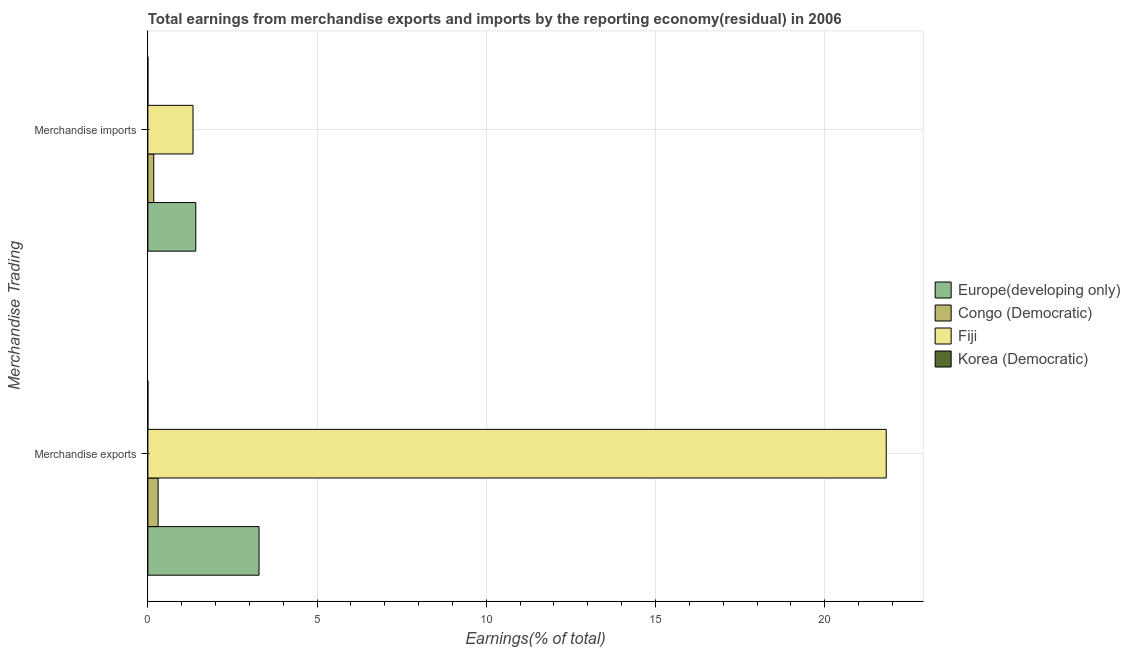How many groups of bars are there?
Give a very brief answer. 2. Are the number of bars per tick equal to the number of legend labels?
Your answer should be very brief. Yes. Are the number of bars on each tick of the Y-axis equal?
Give a very brief answer. Yes. How many bars are there on the 2nd tick from the top?
Offer a very short reply. 4. What is the earnings from merchandise imports in Korea (Democratic)?
Provide a short and direct response. 4.05073146666651e-10. Across all countries, what is the maximum earnings from merchandise imports?
Give a very brief answer. 1.42. Across all countries, what is the minimum earnings from merchandise exports?
Offer a terse response. 2.09451206696143e-8. In which country was the earnings from merchandise exports maximum?
Offer a very short reply. Fiji. In which country was the earnings from merchandise exports minimum?
Provide a succinct answer. Korea (Democratic). What is the total earnings from merchandise imports in the graph?
Provide a short and direct response. 2.92. What is the difference between the earnings from merchandise imports in Fiji and that in Congo (Democratic)?
Make the answer very short. 1.16. What is the difference between the earnings from merchandise imports in Korea (Democratic) and the earnings from merchandise exports in Fiji?
Offer a very short reply. -21.82. What is the average earnings from merchandise exports per country?
Give a very brief answer. 6.35. What is the difference between the earnings from merchandise imports and earnings from merchandise exports in Congo (Democratic)?
Your answer should be compact. -0.13. In how many countries, is the earnings from merchandise imports greater than 12 %?
Your response must be concise. 0. What is the ratio of the earnings from merchandise imports in Europe(developing only) to that in Korea (Democratic)?
Offer a very short reply. 3.50e+09. Is the earnings from merchandise exports in Fiji less than that in Europe(developing only)?
Provide a short and direct response. No. What does the 1st bar from the top in Merchandise imports represents?
Provide a short and direct response. Korea (Democratic). What does the 1st bar from the bottom in Merchandise exports represents?
Your answer should be compact. Europe(developing only). How many bars are there?
Offer a very short reply. 8. Are the values on the major ticks of X-axis written in scientific E-notation?
Your response must be concise. No. Does the graph contain any zero values?
Give a very brief answer. No. Does the graph contain grids?
Keep it short and to the point. Yes. How many legend labels are there?
Give a very brief answer. 4. What is the title of the graph?
Your response must be concise. Total earnings from merchandise exports and imports by the reporting economy(residual) in 2006. Does "Europe(all income levels)" appear as one of the legend labels in the graph?
Your answer should be very brief. No. What is the label or title of the X-axis?
Make the answer very short. Earnings(% of total). What is the label or title of the Y-axis?
Your answer should be compact. Merchandise Trading. What is the Earnings(% of total) of Europe(developing only) in Merchandise exports?
Your answer should be compact. 3.28. What is the Earnings(% of total) in Congo (Democratic) in Merchandise exports?
Keep it short and to the point. 0.3. What is the Earnings(% of total) of Fiji in Merchandise exports?
Give a very brief answer. 21.82. What is the Earnings(% of total) of Korea (Democratic) in Merchandise exports?
Provide a short and direct response. 2.09451206696143e-8. What is the Earnings(% of total) of Europe(developing only) in Merchandise imports?
Offer a very short reply. 1.42. What is the Earnings(% of total) of Congo (Democratic) in Merchandise imports?
Provide a short and direct response. 0.17. What is the Earnings(% of total) in Fiji in Merchandise imports?
Your answer should be very brief. 1.33. What is the Earnings(% of total) of Korea (Democratic) in Merchandise imports?
Your response must be concise. 4.05073146666651e-10. Across all Merchandise Trading, what is the maximum Earnings(% of total) in Europe(developing only)?
Keep it short and to the point. 3.28. Across all Merchandise Trading, what is the maximum Earnings(% of total) of Congo (Democratic)?
Offer a terse response. 0.3. Across all Merchandise Trading, what is the maximum Earnings(% of total) of Fiji?
Ensure brevity in your answer.  21.82. Across all Merchandise Trading, what is the maximum Earnings(% of total) of Korea (Democratic)?
Offer a very short reply. 2.09451206696143e-8. Across all Merchandise Trading, what is the minimum Earnings(% of total) of Europe(developing only)?
Offer a terse response. 1.42. Across all Merchandise Trading, what is the minimum Earnings(% of total) of Congo (Democratic)?
Keep it short and to the point. 0.17. Across all Merchandise Trading, what is the minimum Earnings(% of total) of Fiji?
Ensure brevity in your answer.  1.33. Across all Merchandise Trading, what is the minimum Earnings(% of total) of Korea (Democratic)?
Offer a very short reply. 4.05073146666651e-10. What is the total Earnings(% of total) of Europe(developing only) in the graph?
Your response must be concise. 4.7. What is the total Earnings(% of total) of Congo (Democratic) in the graph?
Your answer should be very brief. 0.48. What is the total Earnings(% of total) in Fiji in the graph?
Your answer should be very brief. 23.15. What is the difference between the Earnings(% of total) of Europe(developing only) in Merchandise exports and that in Merchandise imports?
Provide a succinct answer. 1.87. What is the difference between the Earnings(% of total) in Congo (Democratic) in Merchandise exports and that in Merchandise imports?
Your answer should be very brief. 0.13. What is the difference between the Earnings(% of total) of Fiji in Merchandise exports and that in Merchandise imports?
Offer a terse response. 20.48. What is the difference between the Earnings(% of total) of Korea (Democratic) in Merchandise exports and that in Merchandise imports?
Your answer should be compact. 0. What is the difference between the Earnings(% of total) of Europe(developing only) in Merchandise exports and the Earnings(% of total) of Congo (Democratic) in Merchandise imports?
Give a very brief answer. 3.11. What is the difference between the Earnings(% of total) of Europe(developing only) in Merchandise exports and the Earnings(% of total) of Fiji in Merchandise imports?
Your answer should be compact. 1.95. What is the difference between the Earnings(% of total) in Europe(developing only) in Merchandise exports and the Earnings(% of total) in Korea (Democratic) in Merchandise imports?
Offer a terse response. 3.28. What is the difference between the Earnings(% of total) of Congo (Democratic) in Merchandise exports and the Earnings(% of total) of Fiji in Merchandise imports?
Offer a very short reply. -1.03. What is the difference between the Earnings(% of total) in Congo (Democratic) in Merchandise exports and the Earnings(% of total) in Korea (Democratic) in Merchandise imports?
Offer a terse response. 0.3. What is the difference between the Earnings(% of total) in Fiji in Merchandise exports and the Earnings(% of total) in Korea (Democratic) in Merchandise imports?
Offer a very short reply. 21.82. What is the average Earnings(% of total) of Europe(developing only) per Merchandise Trading?
Give a very brief answer. 2.35. What is the average Earnings(% of total) in Congo (Democratic) per Merchandise Trading?
Keep it short and to the point. 0.24. What is the average Earnings(% of total) of Fiji per Merchandise Trading?
Make the answer very short. 11.58. What is the difference between the Earnings(% of total) of Europe(developing only) and Earnings(% of total) of Congo (Democratic) in Merchandise exports?
Keep it short and to the point. 2.98. What is the difference between the Earnings(% of total) in Europe(developing only) and Earnings(% of total) in Fiji in Merchandise exports?
Provide a short and direct response. -18.53. What is the difference between the Earnings(% of total) in Europe(developing only) and Earnings(% of total) in Korea (Democratic) in Merchandise exports?
Keep it short and to the point. 3.28. What is the difference between the Earnings(% of total) of Congo (Democratic) and Earnings(% of total) of Fiji in Merchandise exports?
Ensure brevity in your answer.  -21.51. What is the difference between the Earnings(% of total) in Congo (Democratic) and Earnings(% of total) in Korea (Democratic) in Merchandise exports?
Offer a terse response. 0.3. What is the difference between the Earnings(% of total) of Fiji and Earnings(% of total) of Korea (Democratic) in Merchandise exports?
Provide a succinct answer. 21.82. What is the difference between the Earnings(% of total) of Europe(developing only) and Earnings(% of total) of Congo (Democratic) in Merchandise imports?
Ensure brevity in your answer.  1.24. What is the difference between the Earnings(% of total) of Europe(developing only) and Earnings(% of total) of Fiji in Merchandise imports?
Your response must be concise. 0.08. What is the difference between the Earnings(% of total) of Europe(developing only) and Earnings(% of total) of Korea (Democratic) in Merchandise imports?
Provide a succinct answer. 1.42. What is the difference between the Earnings(% of total) in Congo (Democratic) and Earnings(% of total) in Fiji in Merchandise imports?
Keep it short and to the point. -1.16. What is the difference between the Earnings(% of total) in Congo (Democratic) and Earnings(% of total) in Korea (Democratic) in Merchandise imports?
Keep it short and to the point. 0.17. What is the difference between the Earnings(% of total) of Fiji and Earnings(% of total) of Korea (Democratic) in Merchandise imports?
Keep it short and to the point. 1.33. What is the ratio of the Earnings(% of total) of Europe(developing only) in Merchandise exports to that in Merchandise imports?
Provide a short and direct response. 2.32. What is the ratio of the Earnings(% of total) in Congo (Democratic) in Merchandise exports to that in Merchandise imports?
Provide a succinct answer. 1.74. What is the ratio of the Earnings(% of total) in Fiji in Merchandise exports to that in Merchandise imports?
Your answer should be compact. 16.35. What is the ratio of the Earnings(% of total) of Korea (Democratic) in Merchandise exports to that in Merchandise imports?
Make the answer very short. 51.71. What is the difference between the highest and the second highest Earnings(% of total) of Europe(developing only)?
Your answer should be very brief. 1.87. What is the difference between the highest and the second highest Earnings(% of total) of Congo (Democratic)?
Your response must be concise. 0.13. What is the difference between the highest and the second highest Earnings(% of total) in Fiji?
Your answer should be compact. 20.48. What is the difference between the highest and the second highest Earnings(% of total) in Korea (Democratic)?
Your answer should be compact. 0. What is the difference between the highest and the lowest Earnings(% of total) of Europe(developing only)?
Keep it short and to the point. 1.87. What is the difference between the highest and the lowest Earnings(% of total) of Congo (Democratic)?
Ensure brevity in your answer.  0.13. What is the difference between the highest and the lowest Earnings(% of total) in Fiji?
Make the answer very short. 20.48. What is the difference between the highest and the lowest Earnings(% of total) of Korea (Democratic)?
Give a very brief answer. 0. 